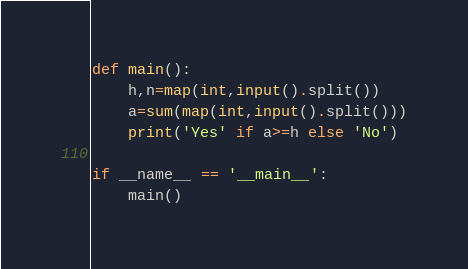Convert code to text. <code><loc_0><loc_0><loc_500><loc_500><_Python_>def main():
    h,n=map(int,input().split())
    a=sum(map(int,input().split()))
    print('Yes' if a>=h else 'No')
    
if __name__ == '__main__':
    main()</code> 